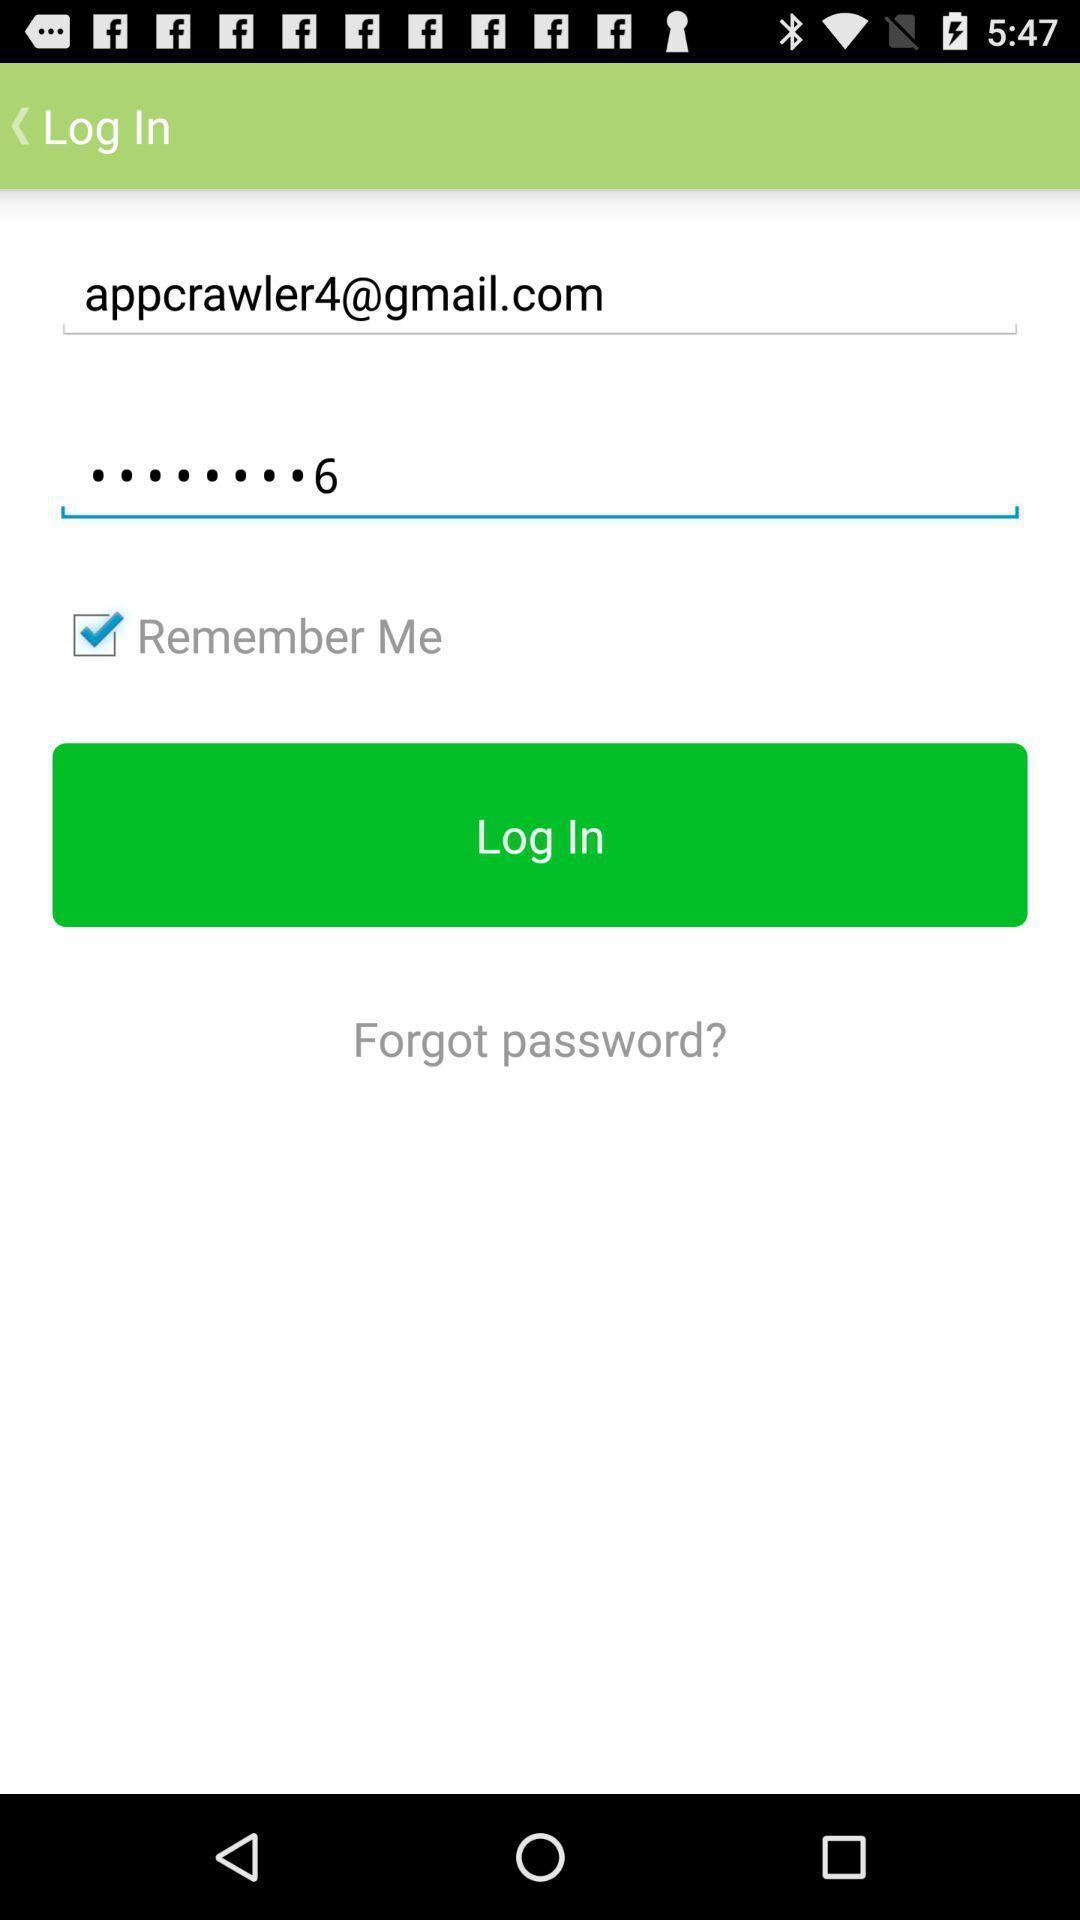Explain what's happening in this screen capture. Login page of an offline dictionary app. 